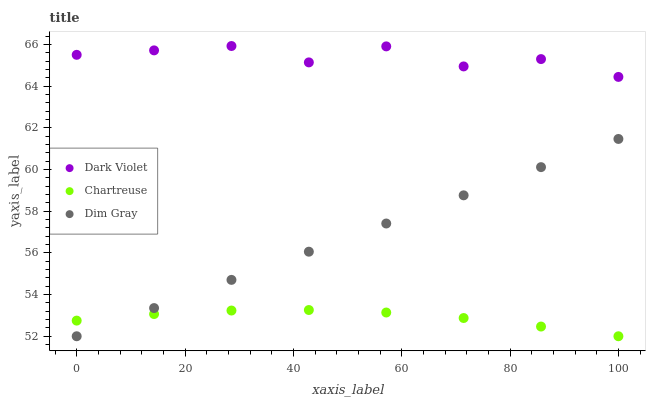Does Chartreuse have the minimum area under the curve?
Answer yes or no. Yes. Does Dark Violet have the maximum area under the curve?
Answer yes or no. Yes. Does Dim Gray have the minimum area under the curve?
Answer yes or no. No. Does Dim Gray have the maximum area under the curve?
Answer yes or no. No. Is Dim Gray the smoothest?
Answer yes or no. Yes. Is Dark Violet the roughest?
Answer yes or no. Yes. Is Dark Violet the smoothest?
Answer yes or no. No. Is Dim Gray the roughest?
Answer yes or no. No. Does Chartreuse have the lowest value?
Answer yes or no. Yes. Does Dark Violet have the lowest value?
Answer yes or no. No. Does Dark Violet have the highest value?
Answer yes or no. Yes. Does Dim Gray have the highest value?
Answer yes or no. No. Is Dim Gray less than Dark Violet?
Answer yes or no. Yes. Is Dark Violet greater than Chartreuse?
Answer yes or no. Yes. Does Dim Gray intersect Chartreuse?
Answer yes or no. Yes. Is Dim Gray less than Chartreuse?
Answer yes or no. No. Is Dim Gray greater than Chartreuse?
Answer yes or no. No. Does Dim Gray intersect Dark Violet?
Answer yes or no. No. 